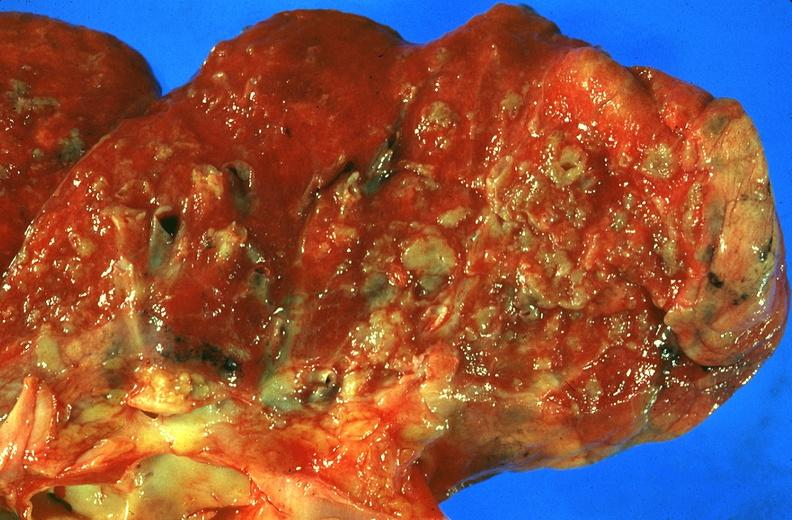what does this image show?
Answer the question using a single word or phrase. Lung 